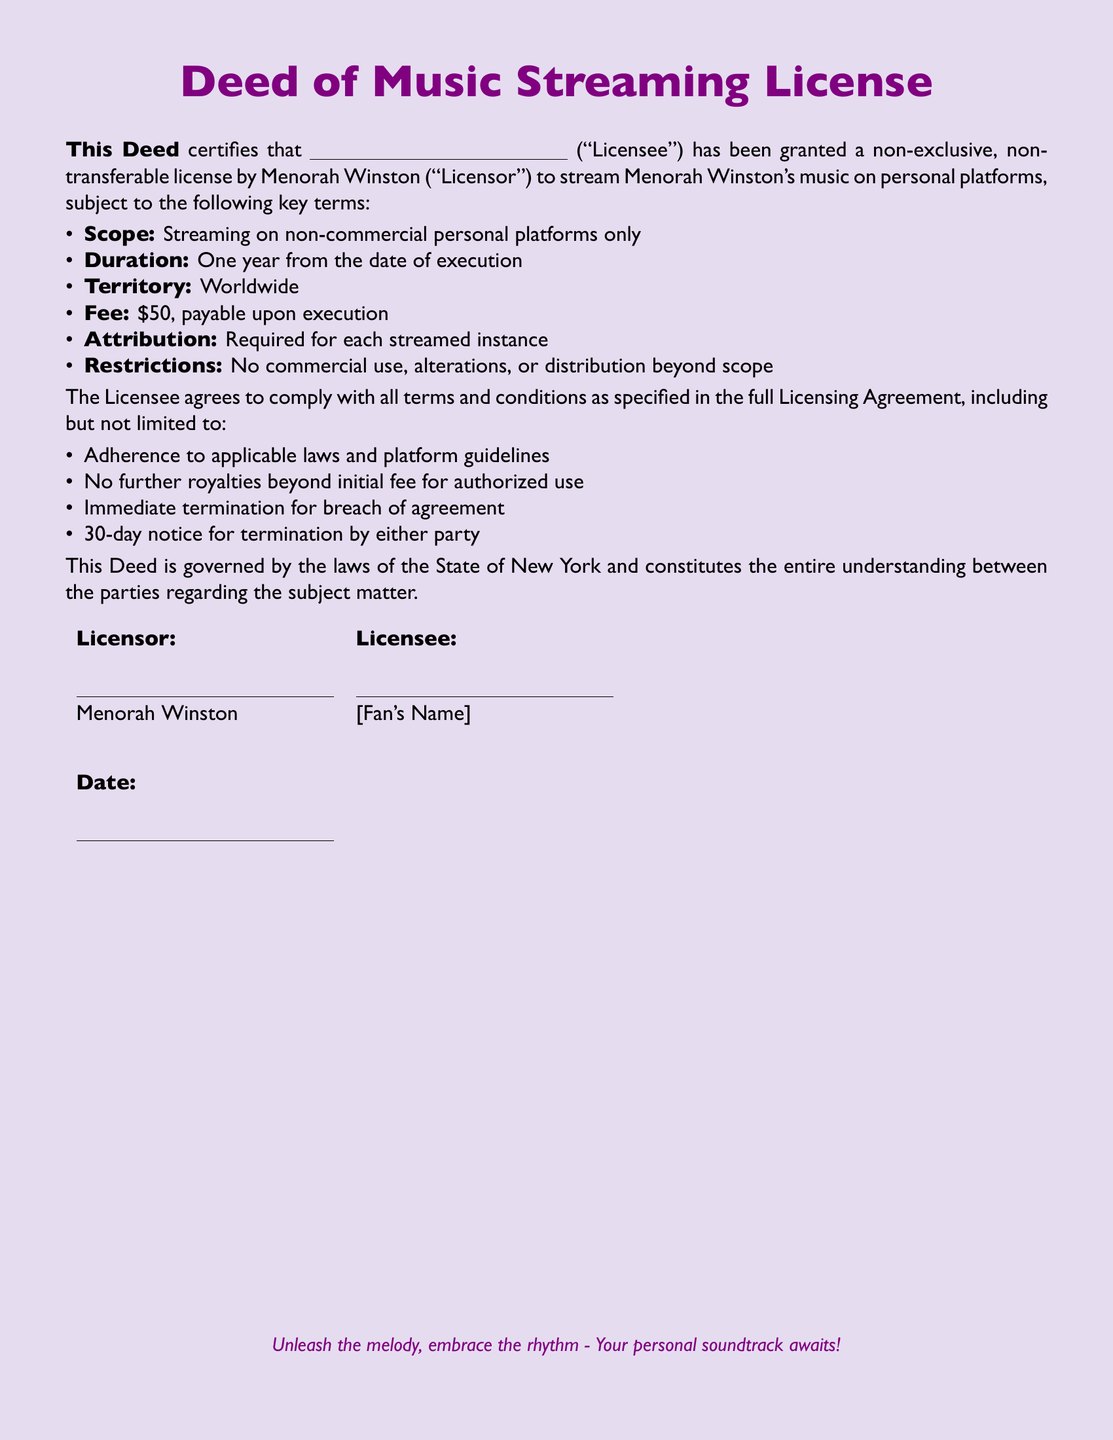What is the name of the Licensor? The Licensor is explicitly mentioned as Menorah Winston in the document.
Answer: Menorah Winston What is the duration of the streaming license? The duration of the license is specified to be one year from the date of execution, according to the terms in the document.
Answer: One year What is the fee for the license? The document states that the fee is $50, which is payable upon execution of the agreement.
Answer: $50 What platform type is allowed for streaming? The scope of the license indicates that streaming is permitted on non-commercial personal platforms only.
Answer: Non-commercial personal platforms What is required for each streamed instance? The document requires attribution for each streamed instance, making it a mandatory condition for the Licensee.
Answer: Attribution Is there any royalty after the initial fee? It is clarified in the document that there are no further royalties beyond the initial fee for authorized use of the music.
Answer: No What will happen in case of a breach of agreement? The document specifies that immediate termination will occur for any breach of the agreement.
Answer: Immediate termination How much notice is needed for termination by either party? The document states that a 30-day notice is required for termination by either party involved in the agreement.
Answer: 30-day notice In which state is this Deed governed? According to the document, the Deed is governed by the laws of the State of New York.
Answer: New York 